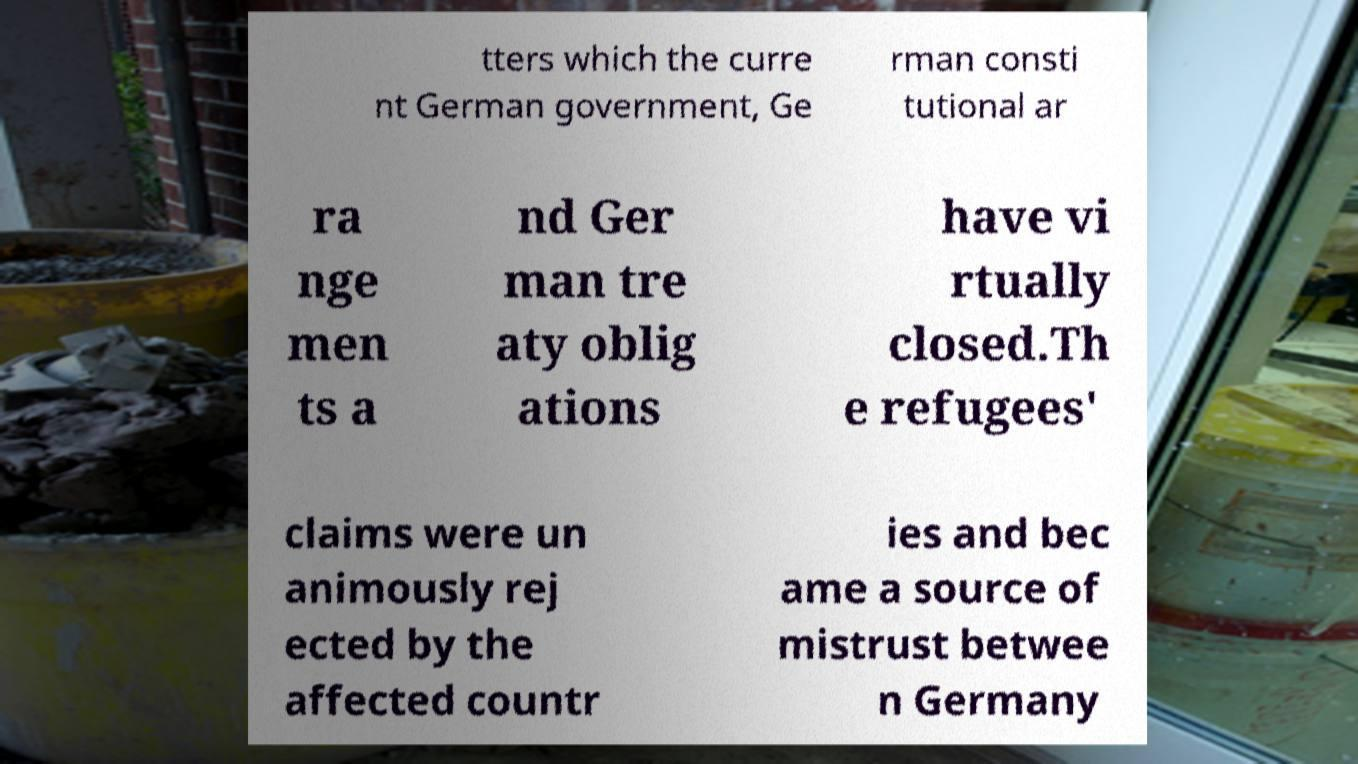Could you assist in decoding the text presented in this image and type it out clearly? tters which the curre nt German government, Ge rman consti tutional ar ra nge men ts a nd Ger man tre aty oblig ations have vi rtually closed.Th e refugees' claims were un animously rej ected by the affected countr ies and bec ame a source of mistrust betwee n Germany 